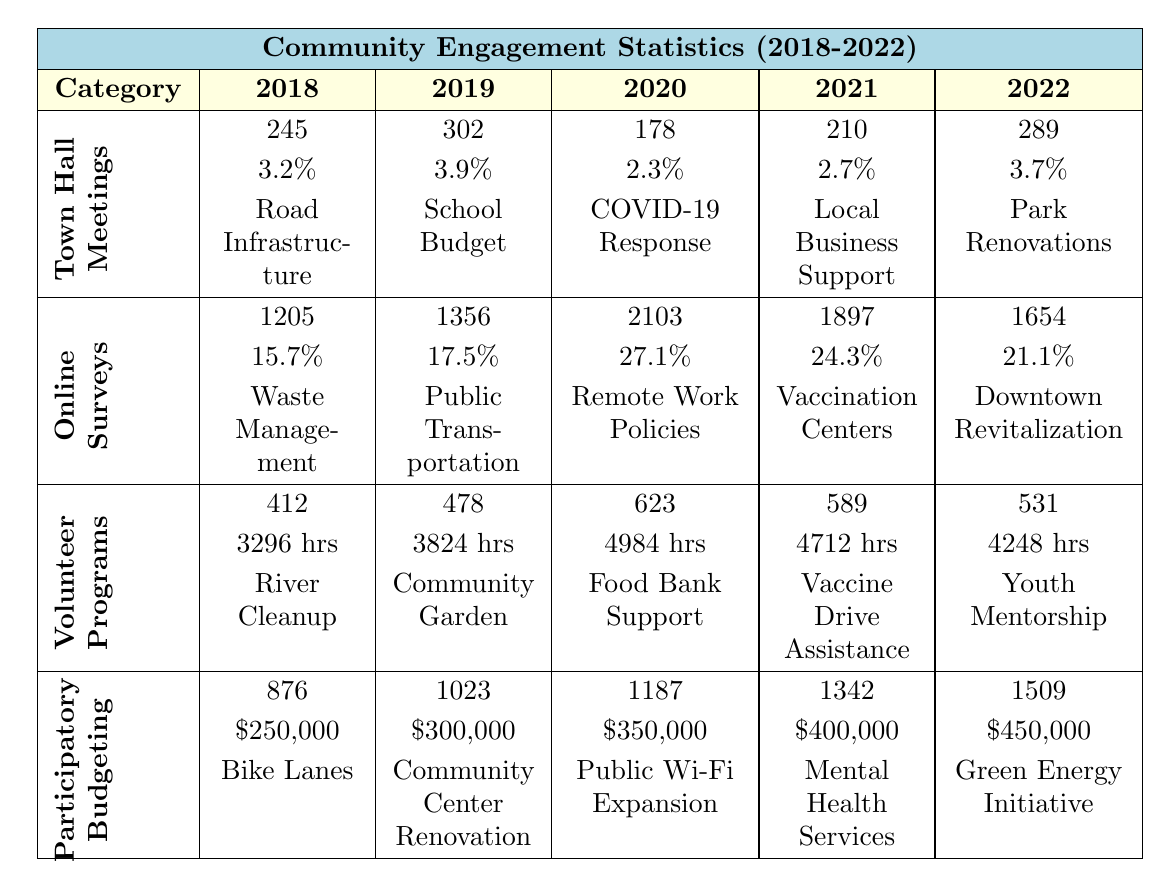What was the total number of attendees at Town Hall Meetings in 2020? The table indicates that in 2020, the Total Attendees at Town Hall Meetings was 178.
Answer: 178 What percentage of the population attended Online Surveys in 2019? According to the table, the Percentage of Population that attended Online Surveys in 2019 was 17.5%.
Answer: 17.5% Which year saw the highest number of volunteers in Volunteer Programs? The table shows that 2020 had the highest number of Total Volunteers, which was 623.
Answer: 2020 What is the difference in total responses to Online Surveys between 2020 and 2022? In 2020, Total Responses to Online Surveys were 2103 and in 2022 it was 1654. The difference is 2103 - 1654 = 449.
Answer: 449 Was the Most Popular Program in Volunteer Programs the same in both 2018 and 2019? According to the table, the Most Popular Program in 2018 was River Cleanup and in 2019 it was Community Garden, so they are different.
Answer: No What was the total budget allocated from Participatory Budgeting in 2021 compared to 2019? In 2021, the Budget Allocated was $400,000 and in 2019 it was $300,000. Subtracting these gives $400,000 - $300,000 = $100,000.
Answer: $100,000 Was there a decrease in attendance at Town Hall Meetings from 2019 to 2020? Yes, the Total Attendees for Town Hall Meetings decreased from 302 in 2019 to 178 in 2020, indicating a drop in attendance.
Answer: Yes What was the average percentage of the population engaged in Online Surveys over the five years? To find the average, we add the percentages (15.7% + 17.5% + 27.1% + 24.3% + 21.1%) = 105.7%, then divide by 5, which gives 105.7% / 5 = 21.14%.
Answer: 21.14% In which year was the project "Mental Health Services" funded through Participatory Budgeting? The table indicates that "Mental Health Services" was the Top Funded Project in 2021.
Answer: 2021 What trend can be observed in the number of attendees at Town Hall Meetings from 2018 to 2022? By looking at the data, we can see that attendance fluctuated but generally increased from 245 in 2018 to 289 in 2022, with a dip in 2020.
Answer: Generally increasing What was the total number of participants in Participatory Budgeting in 2022, and how does it compare to 2018? The Total Participants in 2022 were 1509, and in 2018 it was 876. The difference is 1509 - 876 = 633, showing an increase of 633 participants.
Answer: 633 increase 